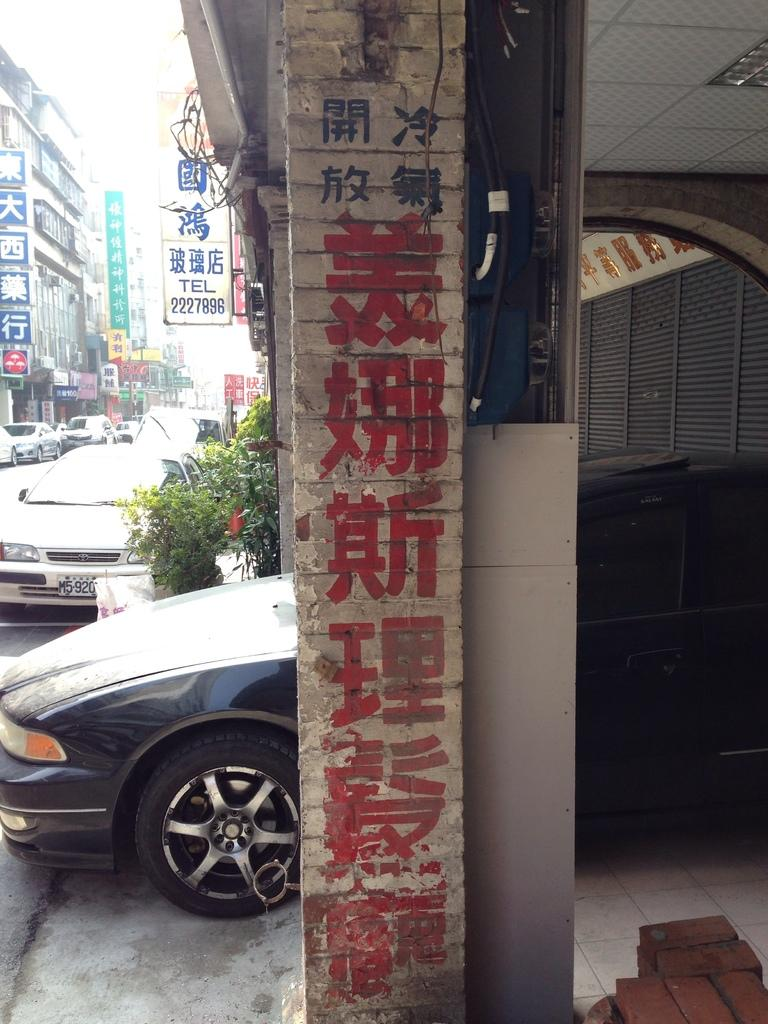What is on the wall in the image? There is writing on the wall in the image. What colors are used for the writing on the wall? The writing on the wall is in red and blue paint. What other objects can be seen in the image? There are cars, buildings, and plants in the image. Where are the cars, buildings, and plants located in the image? The cars, buildings, and plants are located in the right corner of the image. How does the giraffe measure the distance between the buildings in the image? There is no giraffe present in the image, so it cannot measure the distance between the buildings. 